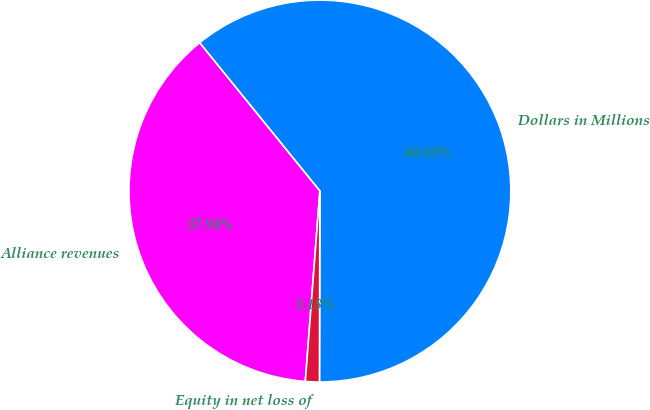Convert chart to OTSL. <chart><loc_0><loc_0><loc_500><loc_500><pie_chart><fcel>Dollars in Millions<fcel>Alliance revenues<fcel>Equity in net loss of<nl><fcel>60.88%<fcel>37.94%<fcel>1.18%<nl></chart> 